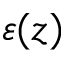<formula> <loc_0><loc_0><loc_500><loc_500>\varepsilon ( z )</formula> 